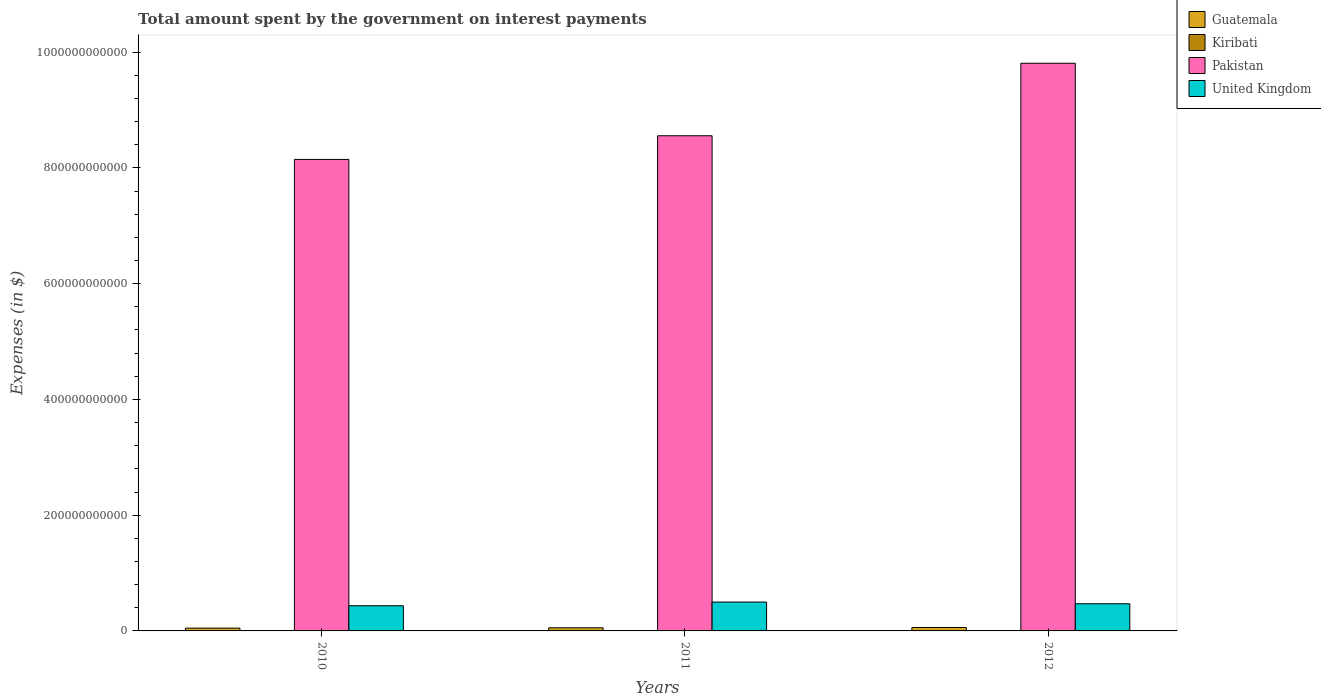How many different coloured bars are there?
Your response must be concise. 4. What is the amount spent on interest payments by the government in Kiribati in 2012?
Your answer should be very brief. 6.19e+06. Across all years, what is the maximum amount spent on interest payments by the government in United Kingdom?
Your answer should be compact. 4.99e+1. Across all years, what is the minimum amount spent on interest payments by the government in United Kingdom?
Provide a short and direct response. 4.35e+1. In which year was the amount spent on interest payments by the government in United Kingdom minimum?
Make the answer very short. 2010. What is the total amount spent on interest payments by the government in Guatemala in the graph?
Ensure brevity in your answer.  1.61e+1. What is the difference between the amount spent on interest payments by the government in Guatemala in 2010 and that in 2011?
Provide a succinct answer. -5.17e+08. What is the difference between the amount spent on interest payments by the government in Guatemala in 2011 and the amount spent on interest payments by the government in Pakistan in 2012?
Your answer should be compact. -9.75e+11. What is the average amount spent on interest payments by the government in United Kingdom per year?
Your response must be concise. 4.68e+1. In the year 2011, what is the difference between the amount spent on interest payments by the government in Kiribati and amount spent on interest payments by the government in Pakistan?
Your response must be concise. -8.55e+11. In how many years, is the amount spent on interest payments by the government in United Kingdom greater than 600000000000 $?
Give a very brief answer. 0. What is the ratio of the amount spent on interest payments by the government in Guatemala in 2010 to that in 2012?
Offer a very short reply. 0.82. Is the difference between the amount spent on interest payments by the government in Kiribati in 2010 and 2011 greater than the difference between the amount spent on interest payments by the government in Pakistan in 2010 and 2011?
Offer a very short reply. Yes. What is the difference between the highest and the second highest amount spent on interest payments by the government in Kiribati?
Your answer should be compact. 3.53e+06. What is the difference between the highest and the lowest amount spent on interest payments by the government in Guatemala?
Offer a terse response. 1.06e+09. Is the sum of the amount spent on interest payments by the government in Kiribati in 2010 and 2012 greater than the maximum amount spent on interest payments by the government in Guatemala across all years?
Ensure brevity in your answer.  No. Is it the case that in every year, the sum of the amount spent on interest payments by the government in United Kingdom and amount spent on interest payments by the government in Pakistan is greater than the sum of amount spent on interest payments by the government in Kiribati and amount spent on interest payments by the government in Guatemala?
Your answer should be compact. No. Is it the case that in every year, the sum of the amount spent on interest payments by the government in Pakistan and amount spent on interest payments by the government in Guatemala is greater than the amount spent on interest payments by the government in United Kingdom?
Your answer should be compact. Yes. What is the difference between two consecutive major ticks on the Y-axis?
Offer a terse response. 2.00e+11. Does the graph contain any zero values?
Make the answer very short. No. Where does the legend appear in the graph?
Your answer should be very brief. Top right. How are the legend labels stacked?
Provide a short and direct response. Vertical. What is the title of the graph?
Keep it short and to the point. Total amount spent by the government on interest payments. Does "Ukraine" appear as one of the legend labels in the graph?
Offer a very short reply. No. What is the label or title of the X-axis?
Keep it short and to the point. Years. What is the label or title of the Y-axis?
Your response must be concise. Expenses (in $). What is the Expenses (in $) in Guatemala in 2010?
Offer a terse response. 4.83e+09. What is the Expenses (in $) in Kiribati in 2010?
Provide a short and direct response. 1.42e+06. What is the Expenses (in $) in Pakistan in 2010?
Ensure brevity in your answer.  8.15e+11. What is the Expenses (in $) of United Kingdom in 2010?
Make the answer very short. 4.35e+1. What is the Expenses (in $) of Guatemala in 2011?
Make the answer very short. 5.35e+09. What is the Expenses (in $) in Kiribati in 2011?
Offer a very short reply. 2.66e+06. What is the Expenses (in $) of Pakistan in 2011?
Your response must be concise. 8.55e+11. What is the Expenses (in $) in United Kingdom in 2011?
Your answer should be very brief. 4.99e+1. What is the Expenses (in $) in Guatemala in 2012?
Your answer should be very brief. 5.89e+09. What is the Expenses (in $) of Kiribati in 2012?
Keep it short and to the point. 6.19e+06. What is the Expenses (in $) in Pakistan in 2012?
Provide a succinct answer. 9.81e+11. What is the Expenses (in $) in United Kingdom in 2012?
Make the answer very short. 4.69e+1. Across all years, what is the maximum Expenses (in $) in Guatemala?
Your response must be concise. 5.89e+09. Across all years, what is the maximum Expenses (in $) of Kiribati?
Your response must be concise. 6.19e+06. Across all years, what is the maximum Expenses (in $) in Pakistan?
Your answer should be compact. 9.81e+11. Across all years, what is the maximum Expenses (in $) of United Kingdom?
Ensure brevity in your answer.  4.99e+1. Across all years, what is the minimum Expenses (in $) of Guatemala?
Your answer should be compact. 4.83e+09. Across all years, what is the minimum Expenses (in $) of Kiribati?
Make the answer very short. 1.42e+06. Across all years, what is the minimum Expenses (in $) of Pakistan?
Give a very brief answer. 8.15e+11. Across all years, what is the minimum Expenses (in $) in United Kingdom?
Make the answer very short. 4.35e+1. What is the total Expenses (in $) of Guatemala in the graph?
Make the answer very short. 1.61e+1. What is the total Expenses (in $) in Kiribati in the graph?
Your answer should be very brief. 1.03e+07. What is the total Expenses (in $) of Pakistan in the graph?
Offer a terse response. 2.65e+12. What is the total Expenses (in $) of United Kingdom in the graph?
Keep it short and to the point. 1.40e+11. What is the difference between the Expenses (in $) in Guatemala in 2010 and that in 2011?
Keep it short and to the point. -5.17e+08. What is the difference between the Expenses (in $) of Kiribati in 2010 and that in 2011?
Your response must be concise. -1.23e+06. What is the difference between the Expenses (in $) in Pakistan in 2010 and that in 2011?
Offer a terse response. -4.09e+1. What is the difference between the Expenses (in $) of United Kingdom in 2010 and that in 2011?
Give a very brief answer. -6.38e+09. What is the difference between the Expenses (in $) in Guatemala in 2010 and that in 2012?
Ensure brevity in your answer.  -1.06e+09. What is the difference between the Expenses (in $) of Kiribati in 2010 and that in 2012?
Offer a terse response. -4.76e+06. What is the difference between the Expenses (in $) in Pakistan in 2010 and that in 2012?
Ensure brevity in your answer.  -1.66e+11. What is the difference between the Expenses (in $) in United Kingdom in 2010 and that in 2012?
Provide a short and direct response. -3.44e+09. What is the difference between the Expenses (in $) of Guatemala in 2011 and that in 2012?
Provide a succinct answer. -5.45e+08. What is the difference between the Expenses (in $) in Kiribati in 2011 and that in 2012?
Keep it short and to the point. -3.53e+06. What is the difference between the Expenses (in $) of Pakistan in 2011 and that in 2012?
Your answer should be compact. -1.25e+11. What is the difference between the Expenses (in $) in United Kingdom in 2011 and that in 2012?
Offer a very short reply. 2.94e+09. What is the difference between the Expenses (in $) of Guatemala in 2010 and the Expenses (in $) of Kiribati in 2011?
Keep it short and to the point. 4.83e+09. What is the difference between the Expenses (in $) of Guatemala in 2010 and the Expenses (in $) of Pakistan in 2011?
Offer a very short reply. -8.51e+11. What is the difference between the Expenses (in $) in Guatemala in 2010 and the Expenses (in $) in United Kingdom in 2011?
Give a very brief answer. -4.50e+1. What is the difference between the Expenses (in $) of Kiribati in 2010 and the Expenses (in $) of Pakistan in 2011?
Ensure brevity in your answer.  -8.55e+11. What is the difference between the Expenses (in $) of Kiribati in 2010 and the Expenses (in $) of United Kingdom in 2011?
Ensure brevity in your answer.  -4.99e+1. What is the difference between the Expenses (in $) of Pakistan in 2010 and the Expenses (in $) of United Kingdom in 2011?
Provide a succinct answer. 7.65e+11. What is the difference between the Expenses (in $) in Guatemala in 2010 and the Expenses (in $) in Kiribati in 2012?
Keep it short and to the point. 4.83e+09. What is the difference between the Expenses (in $) in Guatemala in 2010 and the Expenses (in $) in Pakistan in 2012?
Your answer should be compact. -9.76e+11. What is the difference between the Expenses (in $) in Guatemala in 2010 and the Expenses (in $) in United Kingdom in 2012?
Your answer should be compact. -4.21e+1. What is the difference between the Expenses (in $) of Kiribati in 2010 and the Expenses (in $) of Pakistan in 2012?
Offer a terse response. -9.81e+11. What is the difference between the Expenses (in $) in Kiribati in 2010 and the Expenses (in $) in United Kingdom in 2012?
Keep it short and to the point. -4.69e+1. What is the difference between the Expenses (in $) of Pakistan in 2010 and the Expenses (in $) of United Kingdom in 2012?
Give a very brief answer. 7.68e+11. What is the difference between the Expenses (in $) of Guatemala in 2011 and the Expenses (in $) of Kiribati in 2012?
Offer a very short reply. 5.34e+09. What is the difference between the Expenses (in $) of Guatemala in 2011 and the Expenses (in $) of Pakistan in 2012?
Make the answer very short. -9.75e+11. What is the difference between the Expenses (in $) in Guatemala in 2011 and the Expenses (in $) in United Kingdom in 2012?
Provide a succinct answer. -4.16e+1. What is the difference between the Expenses (in $) of Kiribati in 2011 and the Expenses (in $) of Pakistan in 2012?
Give a very brief answer. -9.81e+11. What is the difference between the Expenses (in $) of Kiribati in 2011 and the Expenses (in $) of United Kingdom in 2012?
Your answer should be very brief. -4.69e+1. What is the difference between the Expenses (in $) of Pakistan in 2011 and the Expenses (in $) of United Kingdom in 2012?
Give a very brief answer. 8.09e+11. What is the average Expenses (in $) of Guatemala per year?
Give a very brief answer. 5.36e+09. What is the average Expenses (in $) in Kiribati per year?
Ensure brevity in your answer.  3.42e+06. What is the average Expenses (in $) of Pakistan per year?
Provide a short and direct response. 8.84e+11. What is the average Expenses (in $) in United Kingdom per year?
Provide a succinct answer. 4.68e+1. In the year 2010, what is the difference between the Expenses (in $) in Guatemala and Expenses (in $) in Kiribati?
Ensure brevity in your answer.  4.83e+09. In the year 2010, what is the difference between the Expenses (in $) of Guatemala and Expenses (in $) of Pakistan?
Provide a succinct answer. -8.10e+11. In the year 2010, what is the difference between the Expenses (in $) of Guatemala and Expenses (in $) of United Kingdom?
Offer a terse response. -3.87e+1. In the year 2010, what is the difference between the Expenses (in $) of Kiribati and Expenses (in $) of Pakistan?
Ensure brevity in your answer.  -8.15e+11. In the year 2010, what is the difference between the Expenses (in $) of Kiribati and Expenses (in $) of United Kingdom?
Provide a succinct answer. -4.35e+1. In the year 2010, what is the difference between the Expenses (in $) of Pakistan and Expenses (in $) of United Kingdom?
Keep it short and to the point. 7.71e+11. In the year 2011, what is the difference between the Expenses (in $) of Guatemala and Expenses (in $) of Kiribati?
Provide a short and direct response. 5.35e+09. In the year 2011, what is the difference between the Expenses (in $) in Guatemala and Expenses (in $) in Pakistan?
Your response must be concise. -8.50e+11. In the year 2011, what is the difference between the Expenses (in $) in Guatemala and Expenses (in $) in United Kingdom?
Your answer should be compact. -4.45e+1. In the year 2011, what is the difference between the Expenses (in $) in Kiribati and Expenses (in $) in Pakistan?
Your answer should be compact. -8.55e+11. In the year 2011, what is the difference between the Expenses (in $) of Kiribati and Expenses (in $) of United Kingdom?
Make the answer very short. -4.99e+1. In the year 2011, what is the difference between the Expenses (in $) of Pakistan and Expenses (in $) of United Kingdom?
Your answer should be compact. 8.06e+11. In the year 2012, what is the difference between the Expenses (in $) of Guatemala and Expenses (in $) of Kiribati?
Your answer should be compact. 5.89e+09. In the year 2012, what is the difference between the Expenses (in $) in Guatemala and Expenses (in $) in Pakistan?
Your response must be concise. -9.75e+11. In the year 2012, what is the difference between the Expenses (in $) of Guatemala and Expenses (in $) of United Kingdom?
Offer a very short reply. -4.10e+1. In the year 2012, what is the difference between the Expenses (in $) of Kiribati and Expenses (in $) of Pakistan?
Provide a short and direct response. -9.81e+11. In the year 2012, what is the difference between the Expenses (in $) of Kiribati and Expenses (in $) of United Kingdom?
Offer a very short reply. -4.69e+1. In the year 2012, what is the difference between the Expenses (in $) in Pakistan and Expenses (in $) in United Kingdom?
Offer a very short reply. 9.34e+11. What is the ratio of the Expenses (in $) in Guatemala in 2010 to that in 2011?
Offer a terse response. 0.9. What is the ratio of the Expenses (in $) in Kiribati in 2010 to that in 2011?
Provide a short and direct response. 0.54. What is the ratio of the Expenses (in $) of Pakistan in 2010 to that in 2011?
Keep it short and to the point. 0.95. What is the ratio of the Expenses (in $) in United Kingdom in 2010 to that in 2011?
Your answer should be very brief. 0.87. What is the ratio of the Expenses (in $) of Guatemala in 2010 to that in 2012?
Ensure brevity in your answer.  0.82. What is the ratio of the Expenses (in $) of Kiribati in 2010 to that in 2012?
Offer a terse response. 0.23. What is the ratio of the Expenses (in $) in Pakistan in 2010 to that in 2012?
Give a very brief answer. 0.83. What is the ratio of the Expenses (in $) of United Kingdom in 2010 to that in 2012?
Offer a terse response. 0.93. What is the ratio of the Expenses (in $) of Guatemala in 2011 to that in 2012?
Provide a short and direct response. 0.91. What is the ratio of the Expenses (in $) in Kiribati in 2011 to that in 2012?
Your response must be concise. 0.43. What is the ratio of the Expenses (in $) of Pakistan in 2011 to that in 2012?
Provide a short and direct response. 0.87. What is the ratio of the Expenses (in $) of United Kingdom in 2011 to that in 2012?
Offer a terse response. 1.06. What is the difference between the highest and the second highest Expenses (in $) of Guatemala?
Ensure brevity in your answer.  5.45e+08. What is the difference between the highest and the second highest Expenses (in $) of Kiribati?
Your answer should be compact. 3.53e+06. What is the difference between the highest and the second highest Expenses (in $) of Pakistan?
Your response must be concise. 1.25e+11. What is the difference between the highest and the second highest Expenses (in $) in United Kingdom?
Your answer should be compact. 2.94e+09. What is the difference between the highest and the lowest Expenses (in $) in Guatemala?
Offer a terse response. 1.06e+09. What is the difference between the highest and the lowest Expenses (in $) in Kiribati?
Your answer should be very brief. 4.76e+06. What is the difference between the highest and the lowest Expenses (in $) in Pakistan?
Your response must be concise. 1.66e+11. What is the difference between the highest and the lowest Expenses (in $) of United Kingdom?
Offer a very short reply. 6.38e+09. 